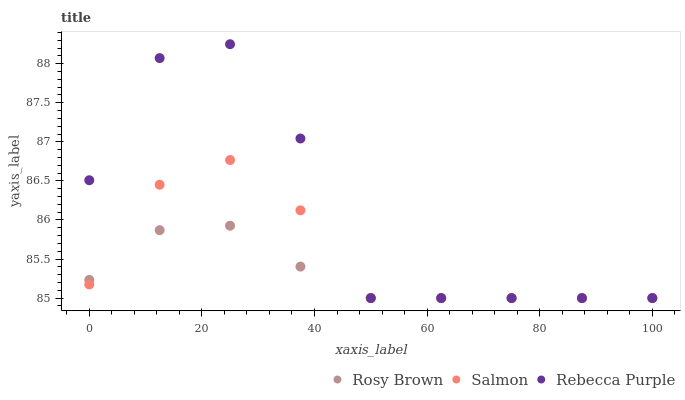Does Rosy Brown have the minimum area under the curve?
Answer yes or no. Yes. Does Rebecca Purple have the maximum area under the curve?
Answer yes or no. Yes. Does Salmon have the minimum area under the curve?
Answer yes or no. No. Does Salmon have the maximum area under the curve?
Answer yes or no. No. Is Rosy Brown the smoothest?
Answer yes or no. Yes. Is Rebecca Purple the roughest?
Answer yes or no. Yes. Is Salmon the smoothest?
Answer yes or no. No. Is Salmon the roughest?
Answer yes or no. No. Does Rosy Brown have the lowest value?
Answer yes or no. Yes. Does Rebecca Purple have the highest value?
Answer yes or no. Yes. Does Salmon have the highest value?
Answer yes or no. No. Does Rebecca Purple intersect Salmon?
Answer yes or no. Yes. Is Rebecca Purple less than Salmon?
Answer yes or no. No. Is Rebecca Purple greater than Salmon?
Answer yes or no. No. 